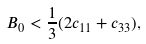<formula> <loc_0><loc_0><loc_500><loc_500>B _ { 0 } < { \frac { 1 } { 3 } } ( 2 c _ { 1 1 } + c _ { 3 3 } ) ,</formula> 